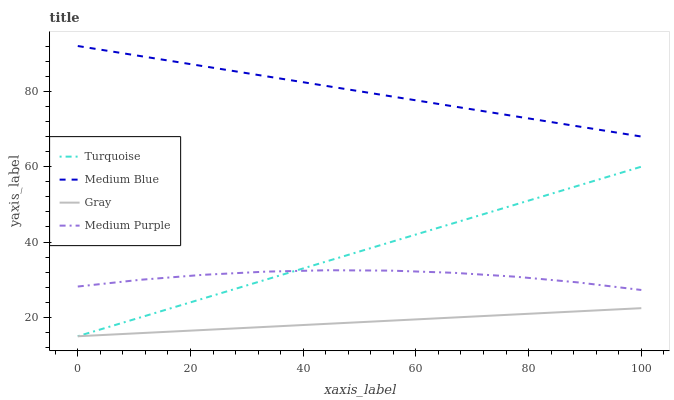Does Gray have the minimum area under the curve?
Answer yes or no. Yes. Does Medium Blue have the maximum area under the curve?
Answer yes or no. Yes. Does Turquoise have the minimum area under the curve?
Answer yes or no. No. Does Turquoise have the maximum area under the curve?
Answer yes or no. No. Is Medium Blue the smoothest?
Answer yes or no. Yes. Is Medium Purple the roughest?
Answer yes or no. Yes. Is Gray the smoothest?
Answer yes or no. No. Is Gray the roughest?
Answer yes or no. No. Does Gray have the lowest value?
Answer yes or no. Yes. Does Medium Blue have the lowest value?
Answer yes or no. No. Does Medium Blue have the highest value?
Answer yes or no. Yes. Does Turquoise have the highest value?
Answer yes or no. No. Is Gray less than Medium Purple?
Answer yes or no. Yes. Is Medium Blue greater than Gray?
Answer yes or no. Yes. Does Medium Purple intersect Turquoise?
Answer yes or no. Yes. Is Medium Purple less than Turquoise?
Answer yes or no. No. Is Medium Purple greater than Turquoise?
Answer yes or no. No. Does Gray intersect Medium Purple?
Answer yes or no. No. 